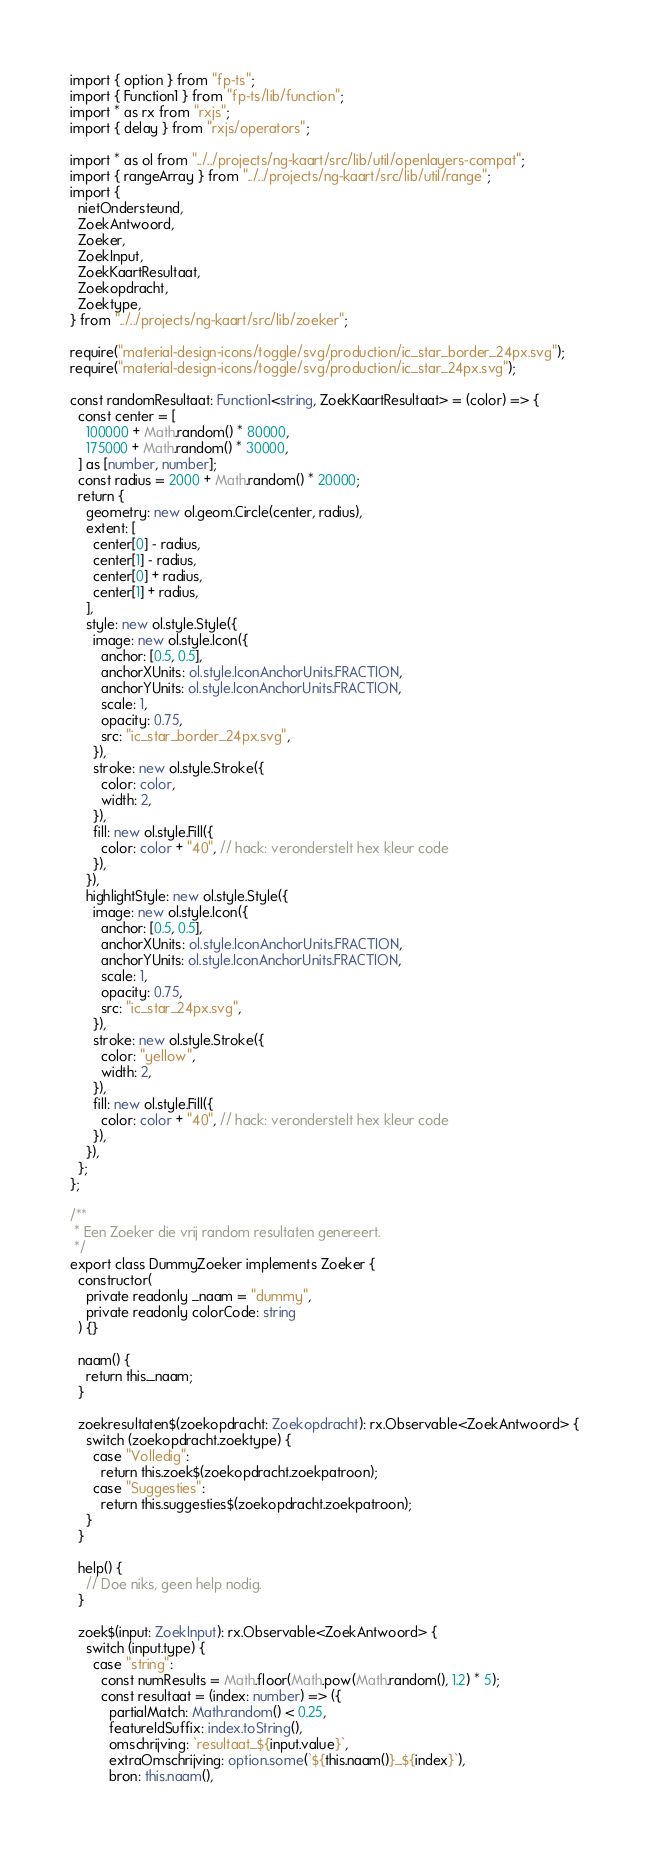Convert code to text. <code><loc_0><loc_0><loc_500><loc_500><_TypeScript_>import { option } from "fp-ts";
import { Function1 } from "fp-ts/lib/function";
import * as rx from "rxjs";
import { delay } from "rxjs/operators";

import * as ol from "../../projects/ng-kaart/src/lib/util/openlayers-compat";
import { rangeArray } from "../../projects/ng-kaart/src/lib/util/range";
import {
  nietOndersteund,
  ZoekAntwoord,
  Zoeker,
  ZoekInput,
  ZoekKaartResultaat,
  Zoekopdracht,
  Zoektype,
} from "../../projects/ng-kaart/src/lib/zoeker";

require("material-design-icons/toggle/svg/production/ic_star_border_24px.svg");
require("material-design-icons/toggle/svg/production/ic_star_24px.svg");

const randomResultaat: Function1<string, ZoekKaartResultaat> = (color) => {
  const center = [
    100000 + Math.random() * 80000,
    175000 + Math.random() * 30000,
  ] as [number, number];
  const radius = 2000 + Math.random() * 20000;
  return {
    geometry: new ol.geom.Circle(center, radius),
    extent: [
      center[0] - radius,
      center[1] - radius,
      center[0] + radius,
      center[1] + radius,
    ],
    style: new ol.style.Style({
      image: new ol.style.Icon({
        anchor: [0.5, 0.5],
        anchorXUnits: ol.style.IconAnchorUnits.FRACTION,
        anchorYUnits: ol.style.IconAnchorUnits.FRACTION,
        scale: 1,
        opacity: 0.75,
        src: "ic_star_border_24px.svg",
      }),
      stroke: new ol.style.Stroke({
        color: color,
        width: 2,
      }),
      fill: new ol.style.Fill({
        color: color + "40", // hack: veronderstelt hex kleur code
      }),
    }),
    highlightStyle: new ol.style.Style({
      image: new ol.style.Icon({
        anchor: [0.5, 0.5],
        anchorXUnits: ol.style.IconAnchorUnits.FRACTION,
        anchorYUnits: ol.style.IconAnchorUnits.FRACTION,
        scale: 1,
        opacity: 0.75,
        src: "ic_star_24px.svg",
      }),
      stroke: new ol.style.Stroke({
        color: "yellow",
        width: 2,
      }),
      fill: new ol.style.Fill({
        color: color + "40", // hack: veronderstelt hex kleur code
      }),
    }),
  };
};

/**
 * Een Zoeker die vrij random resultaten genereert.
 */
export class DummyZoeker implements Zoeker {
  constructor(
    private readonly _naam = "dummy",
    private readonly colorCode: string
  ) {}

  naam() {
    return this._naam;
  }

  zoekresultaten$(zoekopdracht: Zoekopdracht): rx.Observable<ZoekAntwoord> {
    switch (zoekopdracht.zoektype) {
      case "Volledig":
        return this.zoek$(zoekopdracht.zoekpatroon);
      case "Suggesties":
        return this.suggesties$(zoekopdracht.zoekpatroon);
    }
  }

  help() {
    // Doe niks, geen help nodig.
  }

  zoek$(input: ZoekInput): rx.Observable<ZoekAntwoord> {
    switch (input.type) {
      case "string":
        const numResults = Math.floor(Math.pow(Math.random(), 1.2) * 5);
        const resultaat = (index: number) => ({
          partialMatch: Math.random() < 0.25,
          featureIdSuffix: index.toString(),
          omschrijving: `resultaat_${input.value}`,
          extraOmschrijving: option.some(`${this.naam()}_${index}`),
          bron: this.naam(),</code> 